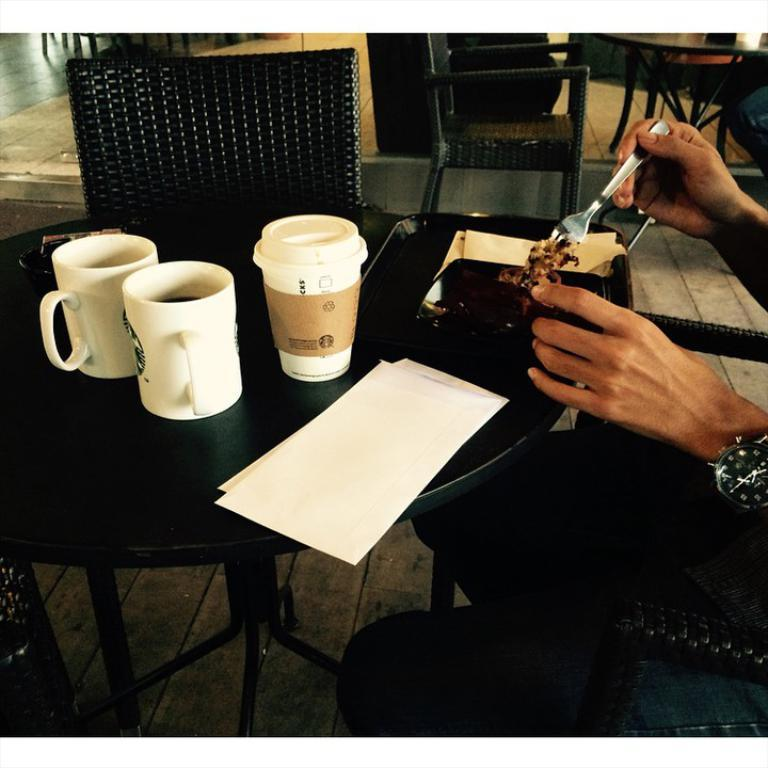What is the main object in the image? There is a table in the image. What is on the table? The table has eatables, drinks, and papers on it. Can you describe the hands in the image? There are hands of a person in the right corner of the image. What type of train can be seen passing by in the image? There is no train present in the image. Is there a downtown area visible in the image? The image does not show a downtown area. 